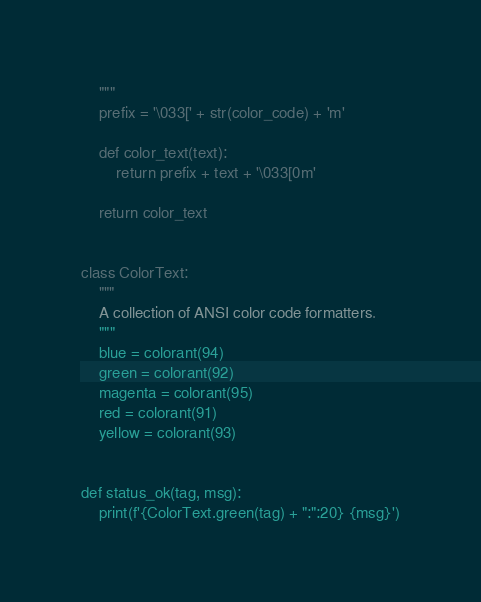Convert code to text. <code><loc_0><loc_0><loc_500><loc_500><_Python_>    """
    prefix = '\033[' + str(color_code) + 'm'

    def color_text(text):
        return prefix + text + '\033[0m'

    return color_text


class ColorText:
    """
    A collection of ANSI color code formatters.
    """
    blue = colorant(94)
    green = colorant(92)
    magenta = colorant(95)
    red = colorant(91)
    yellow = colorant(93)


def status_ok(tag, msg):
    print(f'{ColorText.green(tag) + ":":20} {msg}')
</code> 